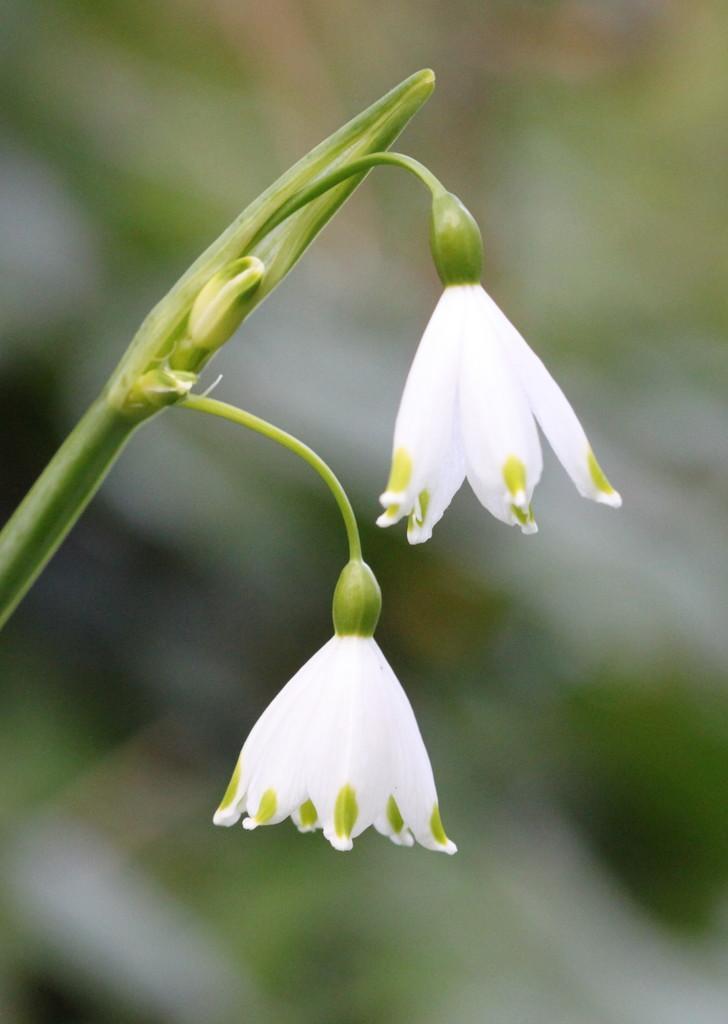Could you give a brief overview of what you see in this image? In this image there are some flowers, stem, background is blurry. 